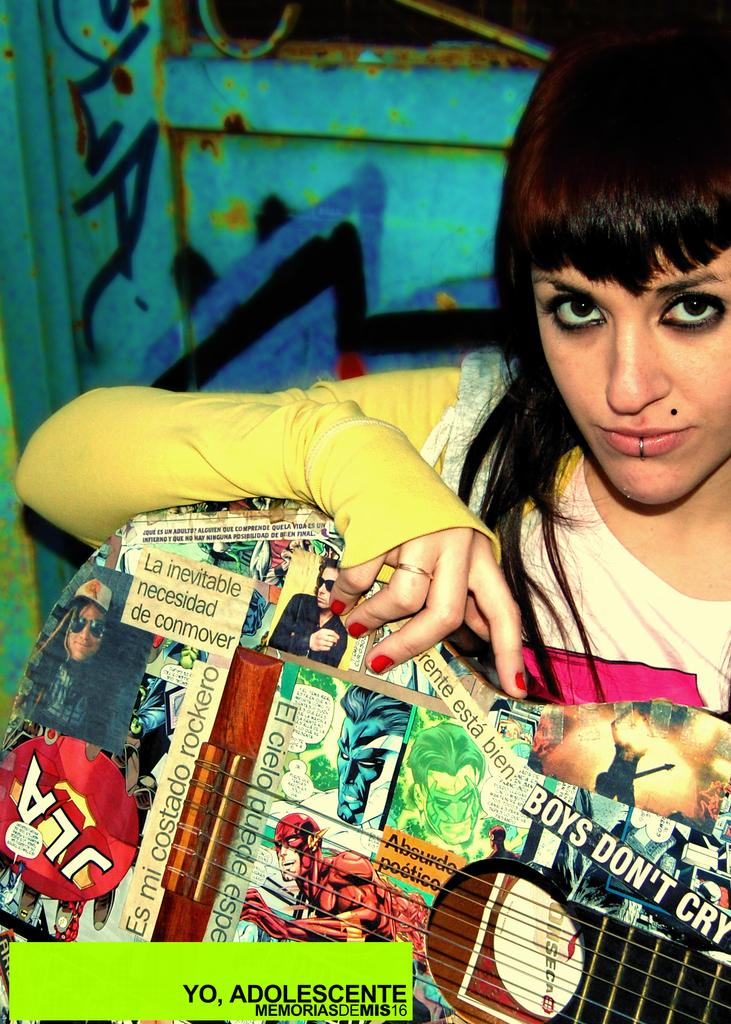<image>
Share a concise interpretation of the image provided. A young girl holding a guitar plastered with stickers that say things like 'Boys Don't Cry'. 